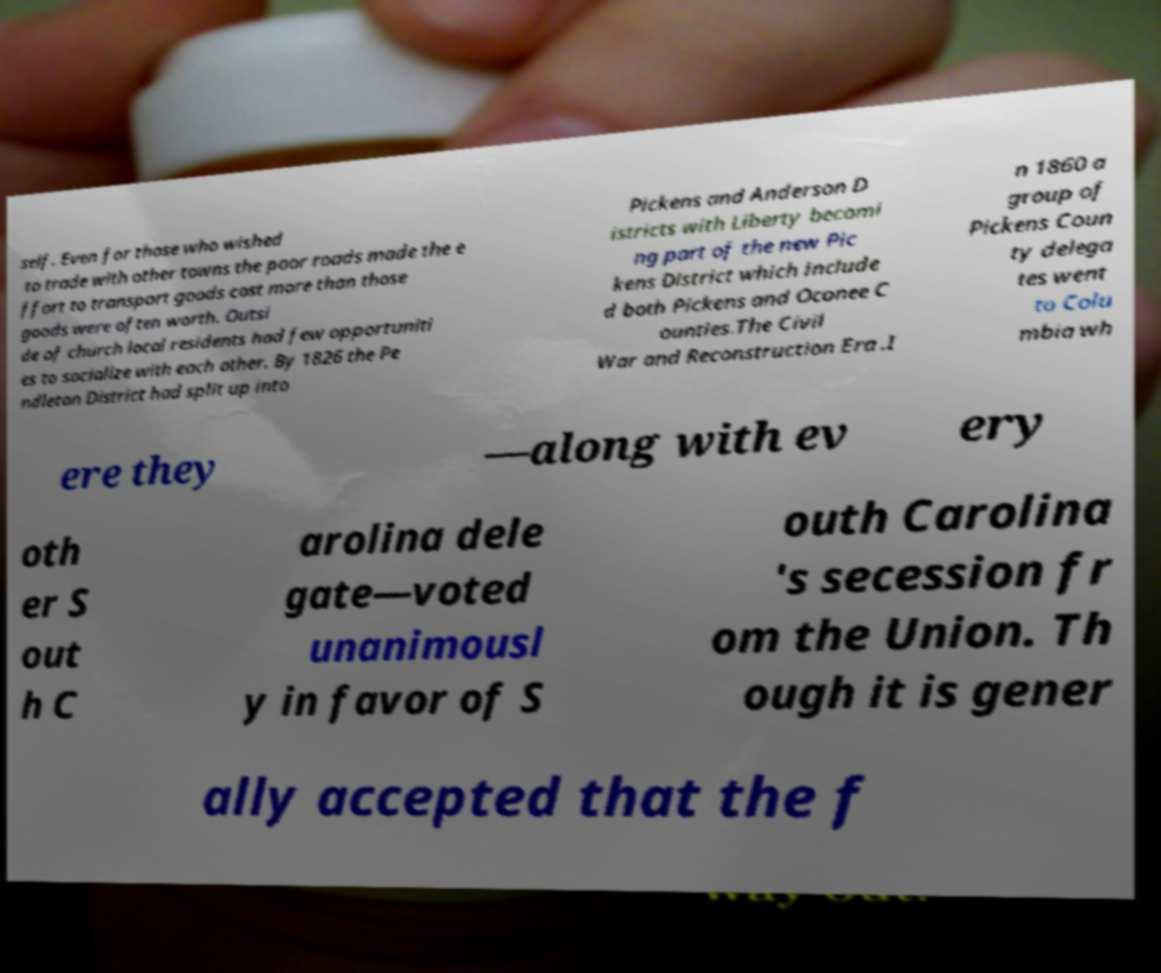There's text embedded in this image that I need extracted. Can you transcribe it verbatim? self. Even for those who wished to trade with other towns the poor roads made the e ffort to transport goods cost more than those goods were often worth. Outsi de of church local residents had few opportuniti es to socialize with each other. By 1826 the Pe ndleton District had split up into Pickens and Anderson D istricts with Liberty becomi ng part of the new Pic kens District which include d both Pickens and Oconee C ounties.The Civil War and Reconstruction Era .I n 1860 a group of Pickens Coun ty delega tes went to Colu mbia wh ere they —along with ev ery oth er S out h C arolina dele gate—voted unanimousl y in favor of S outh Carolina 's secession fr om the Union. Th ough it is gener ally accepted that the f 